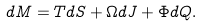Convert formula to latex. <formula><loc_0><loc_0><loc_500><loc_500>d M = T d S + \Omega d J + \Phi d Q .</formula> 